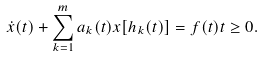Convert formula to latex. <formula><loc_0><loc_0><loc_500><loc_500>\dot { x } ( t ) + \sum _ { k = 1 } ^ { m } a _ { k } ( t ) x [ h _ { k } ( t ) ] = f ( t ) t \geq 0 .</formula> 